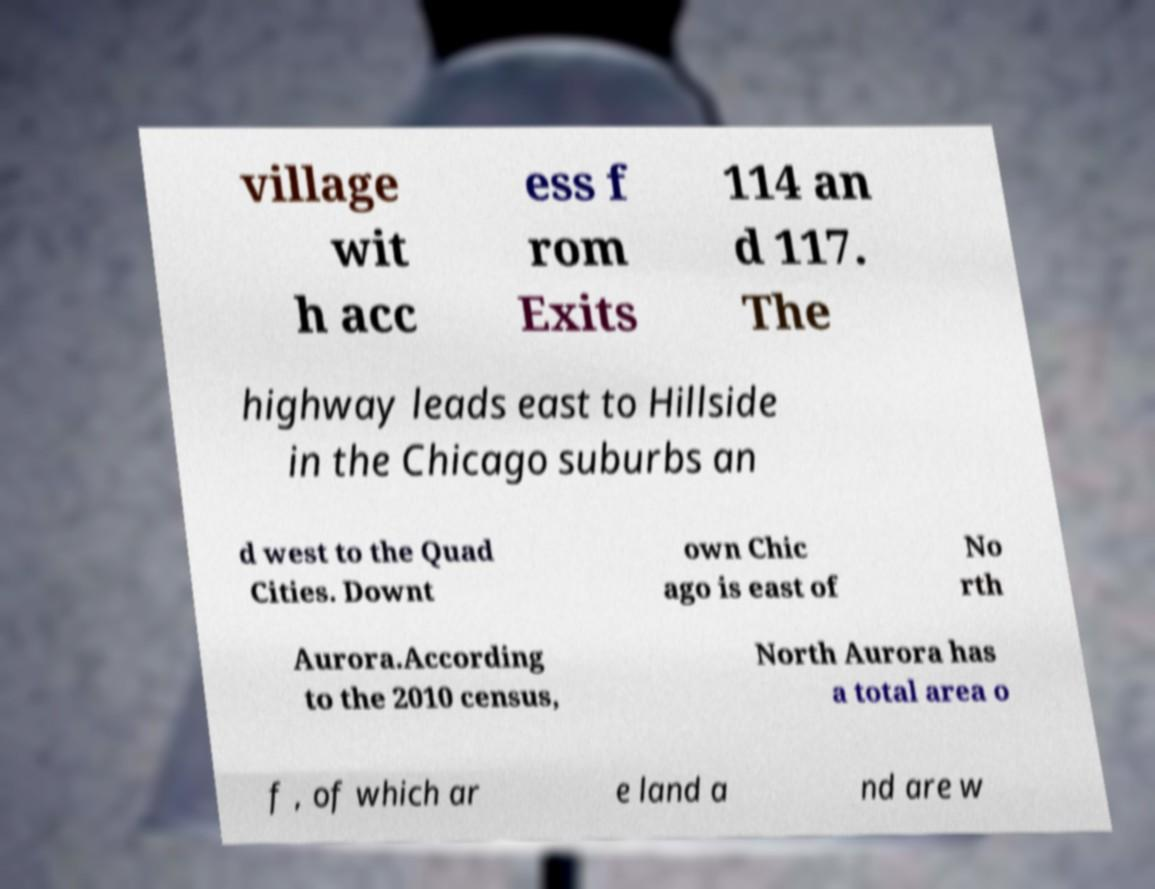What messages or text are displayed in this image? I need them in a readable, typed format. village wit h acc ess f rom Exits 114 an d 117. The highway leads east to Hillside in the Chicago suburbs an d west to the Quad Cities. Downt own Chic ago is east of No rth Aurora.According to the 2010 census, North Aurora has a total area o f , of which ar e land a nd are w 